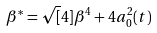Convert formula to latex. <formula><loc_0><loc_0><loc_500><loc_500>\beta ^ { * } = \sqrt { [ } 4 ] { \beta ^ { 4 } + 4 a _ { 0 } ^ { 2 } ( t ) }</formula> 